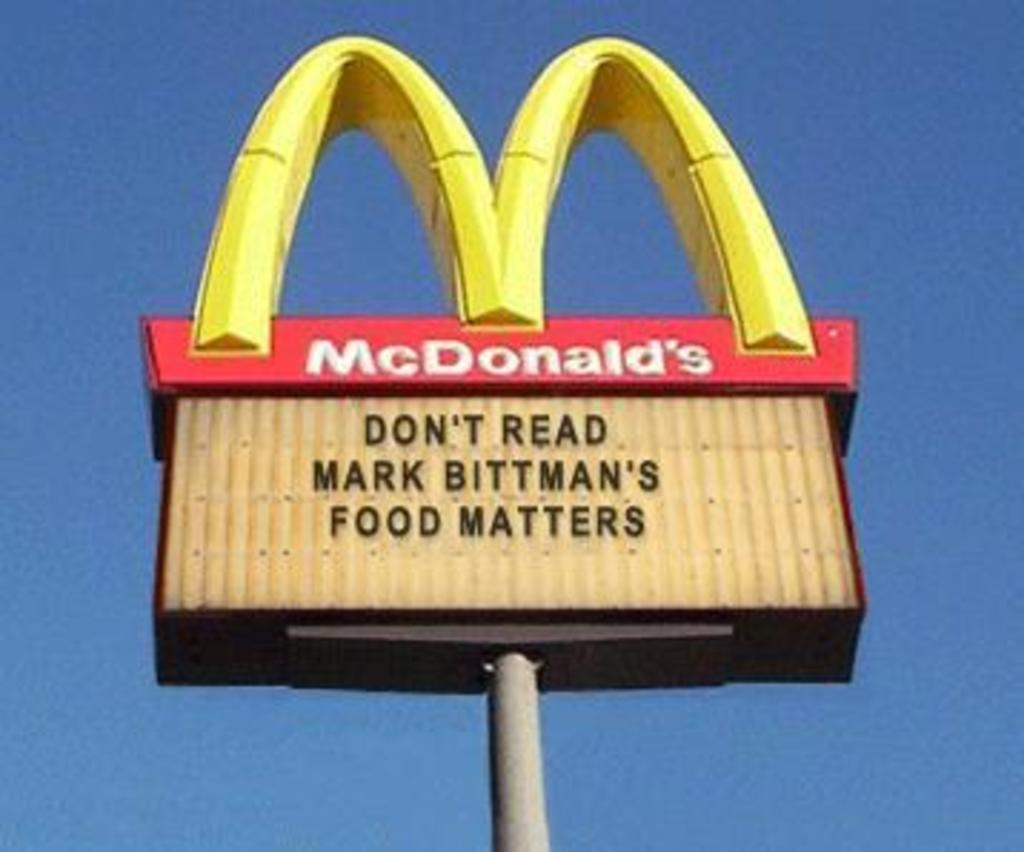<image>
Offer a succinct explanation of the picture presented. A McDonald's sign encourages people not to read Mark Bittman's book. 